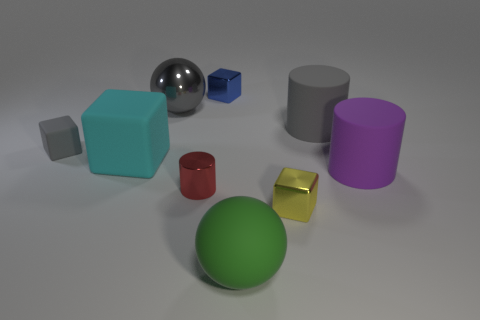If this image were used in an advertisement, what product or concept might it be promoting? This image, with its clean, minimalist setting and array of colorful, simple shapes, could be used to promote a range of products, from children's toys to a creative software suite or even an interior design service focusing on modern aesthetics. 